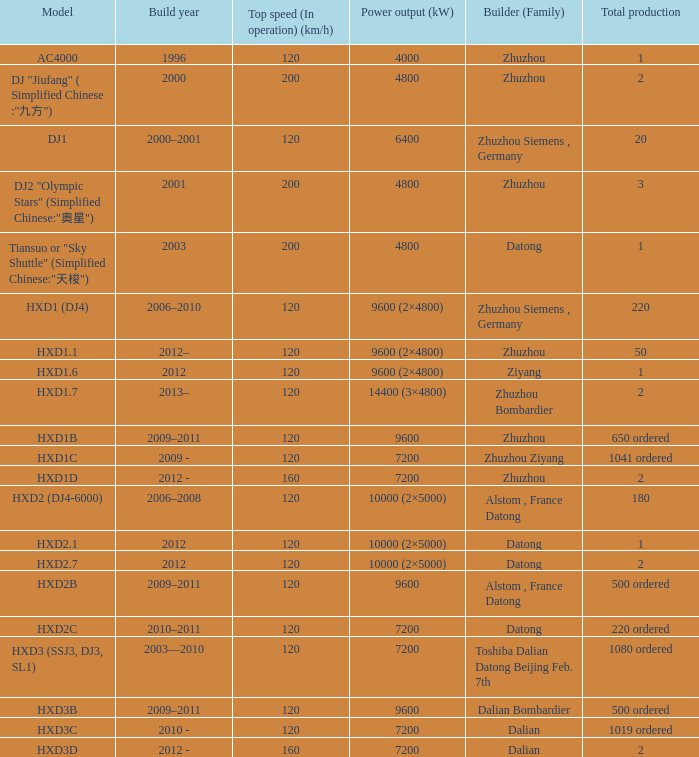What is the power output (kw) of model hxd3d? 7200.0. 